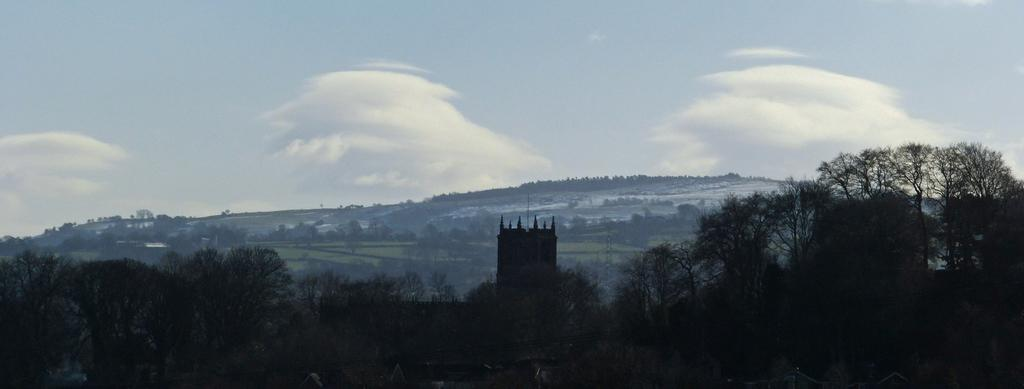What type of landscape can be seen in the image? The image features hills, trees, and fields. What structure is present in the image? There is a tower in the image. What is visible in the background of the image? The sky is visible in the background of the image. Can you see the face of the hill in the image? There is no face present on the hills in the image. Is the image taken on an island? The provided facts do not mention anything about an island, so it cannot be determined from the image. 